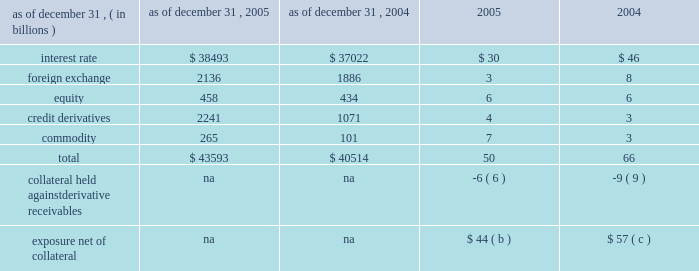Notional amounts and derivative receivables marked to market ( 201cmtm 201d ) notional amounts ( a ) derivative receivables mtm as of december 31 .
( a ) the notional amounts represent the gross sum of long and short third-party notional derivative contracts , excluding written options and foreign exchange spot contracts , which significantly exceed the possible credit losses that could arise from such transactions .
For most derivative transactions , the notional principal amount does not change hands ; it is used simply as a reference to calculate payments .
( b ) the firm held $ 33 billion of collateral against derivative receivables as of december 31 , 2005 , consisting of $ 27 billion in net cash received under credit support annexes to legally enforceable master netting agreements , and $ 6 billion of other liquid securities collateral .
The benefit of the $ 27 billion is reflected within the $ 50 billion of derivative receivables mtm .
Excluded from the $ 33 billion of collateral is $ 10 billion of collateral delivered by clients at the initiation of transactions ; this collateral secures exposure that could arise in the derivatives portfolio should the mtm of the client 2019s transactions move in the firm 2019s favor .
Also excluded are credit enhancements in the form of letters of credit and surety receivables .
( c ) the firm held $ 41 billion of collateral against derivative receivables as of december 31 , 2004 , consisting of $ 32 billion in net cash received under credit support annexes to legally enforceable master netting agreements , and $ 9 billion of other liquid securities collateral .
The benefit of the $ 32 billion is reflected within the $ 66 billion of derivative receivables mtm .
Excluded from the $ 41 billion of collateral is $ 10 billion of collateral delivered by clients at the initiation of transactions ; this collateral secures exposure that could arise in the derivatives portfolio should the mtm of the client 2019s transactions move in the firm 2019s favor .
Also excluded are credit enhancements in the form of letters of credit and surety receivables .
Management 2019s discussion and analysis jpmorgan chase & co .
68 jpmorgan chase & co .
/ 2005 annual report 1 year 2 years 5 years 10 years mdp avgavgdredre exposure profile of derivatives measures december 31 , 2005 ( in billions ) the following table summarizes the aggregate notional amounts and the reported derivative receivables ( i.e. , the mtm or fair value of the derivative contracts after taking into account the effects of legally enforceable master netting agreements ) at each of the dates indicated : the mtm of derivative receivables contracts represents the cost to replace the contracts at current market rates should the counterparty default .
When jpmorgan chase has more than one transaction outstanding with a counter- party , and a legally enforceable master netting agreement exists with that counterparty , the netted mtm exposure , less collateral held , represents , in the firm 2019s view , the appropriate measure of current credit risk .
While useful as a current view of credit exposure , the net mtm value of the derivative receivables does not capture the potential future variability of that credit exposure .
To capture the potential future variability of credit exposure , the firm calculates , on a client-by-client basis , three measures of potential derivatives-related credit loss : peak , derivative risk equivalent ( 201cdre 201d ) and average exposure ( 201cavg 201d ) .
These measures all incorporate netting and collateral benefits , where applicable .
Peak exposure to a counterparty is an extreme measure of exposure calculated at a 97.5% ( 97.5 % ) confidence level .
However , the total potential future credit risk embedded in the firm 2019s derivatives portfolio is not the simple sum of all peak client credit risks .
This is because , at the portfolio level , credit risk is reduced by the fact that when offsetting transactions are done with separate counter- parties , only one of the two trades can generate a credit loss , even if both counterparties were to default simultaneously .
The firm refers to this effect as market diversification , and the market-diversified peak ( 201cmdp 201d ) measure is a portfolio aggregation of counterparty peak measures , representing the maximum losses at the 97.5% ( 97.5 % ) confidence level that would occur if all coun- terparties defaulted under any one given market scenario and time frame .
Derivative risk equivalent ( 201cdre 201d ) exposure is a measure that expresses the riskiness of derivative exposure on a basis intended to be equivalent to the riskiness of loan exposures .
The measurement is done by equating the unexpected loss in a derivative counterparty exposure ( which takes into consideration both the loss volatility and the credit rating of the counterparty ) with the unexpected loss in a loan exposure ( which takes into consideration only the credit rating of the counterparty ) .
Dre is a less extreme measure of potential credit loss than peak and is the primary measure used by the firm for credit approval of derivative transactions .
Finally , average exposure ( 201cavg 201d ) is a measure of the expected mtm value of the firm 2019s derivative receivables at future time periods , including the benefit of collateral .
Avg exposure over the total life of the derivative contract is used as the primary metric for pricing purposes and is used to calculate credit capital and the credit valuation adjustment ( 201ccva 201d ) , as further described below .
Average exposure was $ 36 billion and $ 38 billion at december 31 , 2005 and 2004 , respectively , compared with derivative receivables mtm net of other highly liquid collateral of $ 44 billion and $ 57 billion at december 31 , 2005 and 2004 , respectively .
The graph below shows exposure profiles to derivatives over the next 10 years as calculated by the mdp , dre and avg metrics .
All three measures generally show declining exposure after the first year , if no new trades were added to the portfolio. .
For the derivative contracts , assuming an average contract life of 10 years , what would annual exposure be in us$ billion at december 31 , 2005 on derivative receivables? 
Computations: (36 / 10)
Answer: 3.6. 